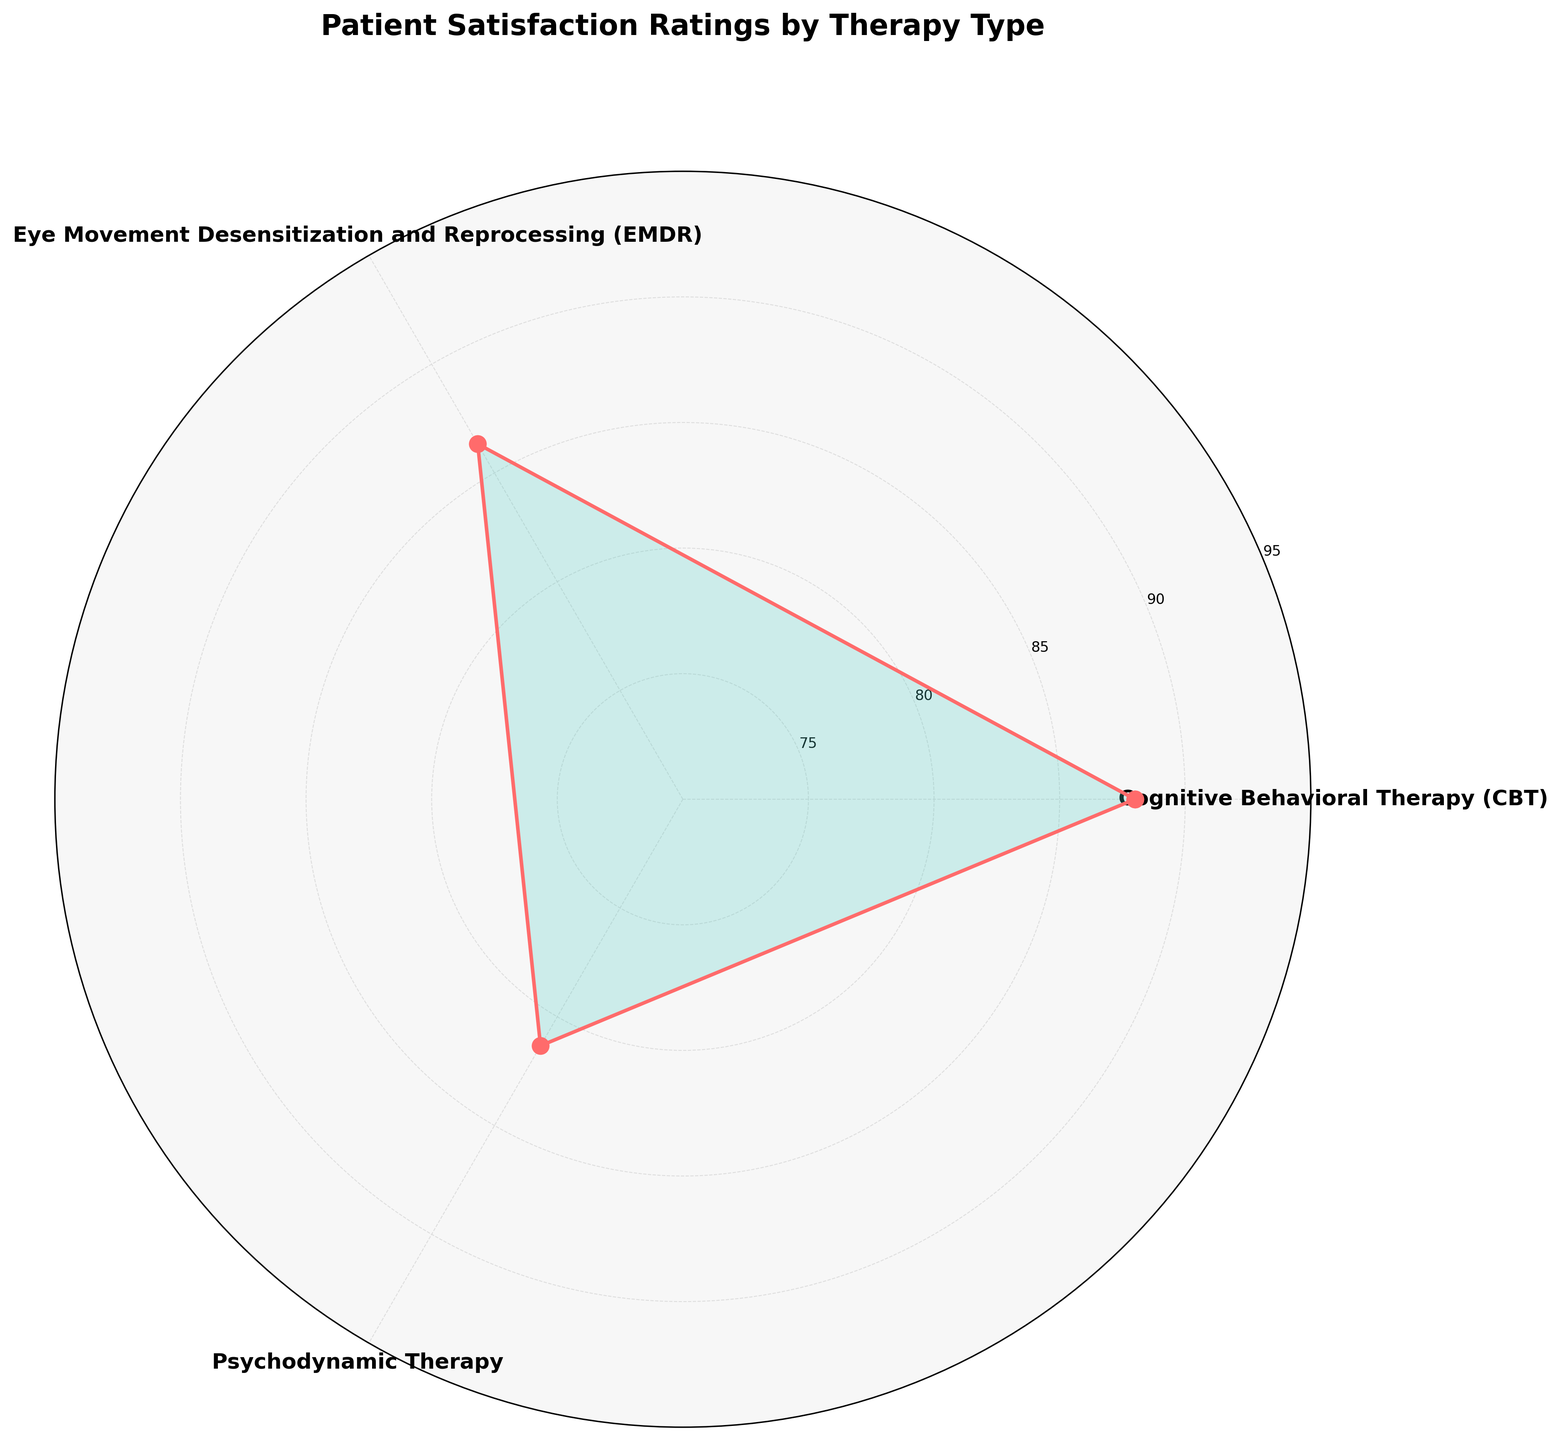what is the title of the chart? The title of the chart is displayed at the top and reads "Patient Satisfaction Ratings by Therapy Type".
Answer: Patient Satisfaction Ratings by Therapy Type what are the therapy types shown in the chart? The labels on the polar chart indicate three therapy types: Cognitive Behavioral Therapy (CBT), Eye Movement Desensitization and Reprocessing (EMDR), and Psychodynamic Therapy.
Answer: Cognitive Behavioral Therapy (CBT), Eye Movement Desensitization and Reprocessing (EMDR), Psychodynamic Therapy what is the average patient satisfaction rating for Cognitive Behavioral Therapy (CBT)? The average patient satisfaction rating for Cognitive Behavioral Therapy (CBT) is marked by one of the points on the chart, falling midway on the scale used. The value displayed next to the label for Cognitive Behavioral Therapy shows this average rating.
Answer: 88.0 which therapy type achieved the highest average patient satisfaction rating? By comparing the points on the chart, it is evident that Cognitive Behavioral Therapy (CBT) has the highest point among the three therapy types, indicating the highest average patient satisfaction rating.
Answer: Cognitive Behavioral Therapy (CBT) what is the range of patient satisfaction ratings displayed on the vertical axis? The radial grids in the chart display the scale used for ratings, which ranges from 75 to 95, according to the tick labels on the vertical axis.
Answer: 75 to 95 how do the patient satisfaction ratings for Eye Movement Desensitization and Reprocessing (EMDR) compare to Psychodynamic Therapy? Comparing the position of the points for Eye Movement Desensitization and Reprocessing (EMDR) and Psychodynamic Therapy on the chart reveals that EMDR has higher average ratings than Psychodynamic Therapy.
Answer: Higher which group shows the smallest average satisfaction rating? Looking at the chart, Psychodynamic Therapy has the lowest point among the three groups, indicating the smallest average satisfaction rating.
Answer: Psychodynamic Therapy what is the difference in average satisfaction ratings between Cognitive Behavioral Therapy (CBT) and Psychodynamic Therapy? The average rating for CBT is 88.0 and for Psychodynamic Therapy is 81.33 (calculated from chart details). The difference is calculated as 88.0 - 81.33 = 6.67.
Answer: 6.67 what does the colored area inside the chart represent? The filled area in the chart represents the range of average patient satisfaction ratings for the different therapy types, with colors helping illustrate differences among groups.
Answer: range of average satisfaction ratings 